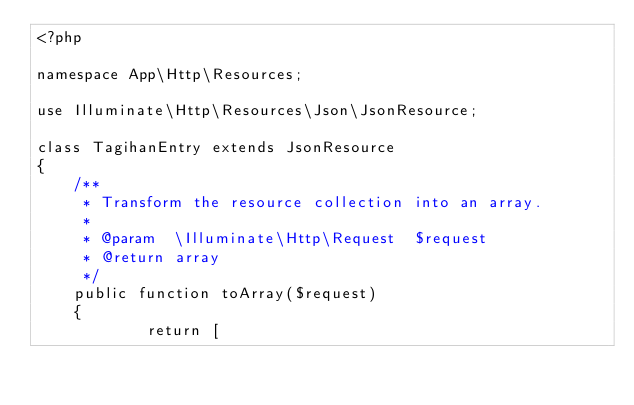Convert code to text. <code><loc_0><loc_0><loc_500><loc_500><_PHP_><?php

namespace App\Http\Resources;

use Illuminate\Http\Resources\Json\JsonResource;

class TagihanEntry extends JsonResource
{
    /**
     * Transform the resource collection into an array.
     *
     * @param  \Illuminate\Http\Request  $request
     * @return array
     */
    public function toArray($request)
    {
            return [</code> 